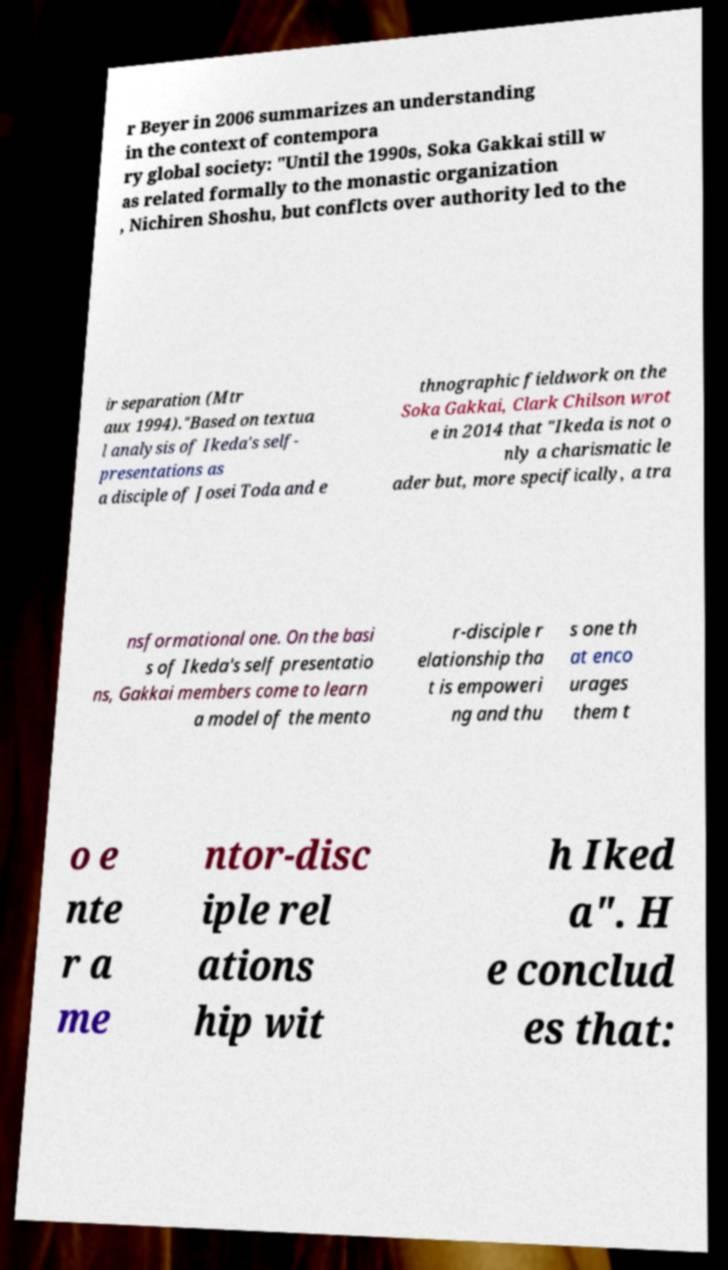Please identify and transcribe the text found in this image. r Beyer in 2006 summarizes an understanding in the context of contempora ry global society: "Until the 1990s, Soka Gakkai still w as related formally to the monastic organization , Nichiren Shoshu, but conflcts over authority led to the ir separation (Mtr aux 1994)."Based on textua l analysis of Ikeda's self- presentations as a disciple of Josei Toda and e thnographic fieldwork on the Soka Gakkai, Clark Chilson wrot e in 2014 that "Ikeda is not o nly a charismatic le ader but, more specifically, a tra nsformational one. On the basi s of Ikeda's self presentatio ns, Gakkai members come to learn a model of the mento r-disciple r elationship tha t is empoweri ng and thu s one th at enco urages them t o e nte r a me ntor-disc iple rel ations hip wit h Iked a". H e conclud es that: 